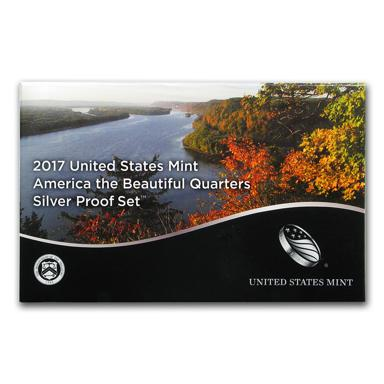What is the name of the silver proof set mentioned in the image? The silver proof set shown in the image is identified as the "2017 United States Mint America the Beautiful Quarters Silver Proof Set." This collectible set features quarters that depict various national parks and sites in the United States, highlighted by its beautifully designed package incorporating an autumnal landscape. 